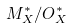Convert formula to latex. <formula><loc_0><loc_0><loc_500><loc_500>M _ { X } ^ { * } / O _ { X } ^ { * }</formula> 